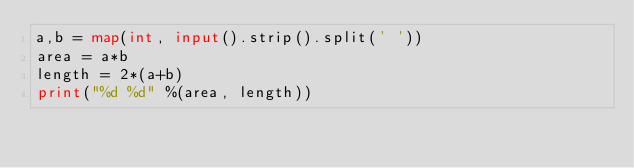Convert code to text. <code><loc_0><loc_0><loc_500><loc_500><_Python_>a,b = map(int, input().strip().split(' '))
area = a*b
length = 2*(a+b)
print("%d %d" %(area, length))

</code> 